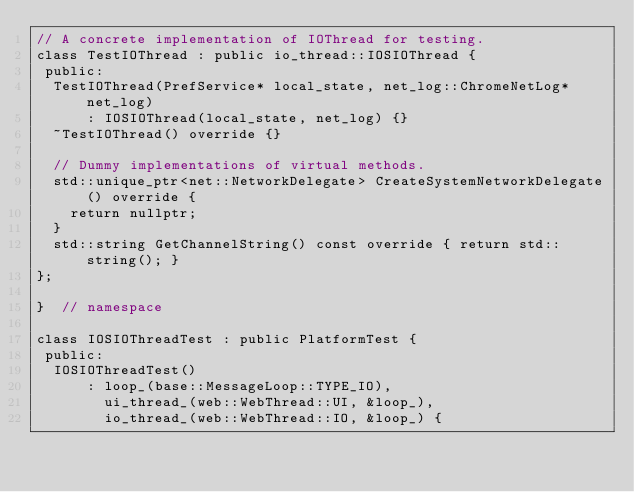<code> <loc_0><loc_0><loc_500><loc_500><_ObjectiveC_>// A concrete implementation of IOThread for testing.
class TestIOThread : public io_thread::IOSIOThread {
 public:
  TestIOThread(PrefService* local_state, net_log::ChromeNetLog* net_log)
      : IOSIOThread(local_state, net_log) {}
  ~TestIOThread() override {}

  // Dummy implementations of virtual methods.
  std::unique_ptr<net::NetworkDelegate> CreateSystemNetworkDelegate() override {
    return nullptr;
  }
  std::string GetChannelString() const override { return std::string(); }
};

}  // namespace

class IOSIOThreadTest : public PlatformTest {
 public:
  IOSIOThreadTest()
      : loop_(base::MessageLoop::TYPE_IO),
        ui_thread_(web::WebThread::UI, &loop_),
        io_thread_(web::WebThread::IO, &loop_) {</code> 